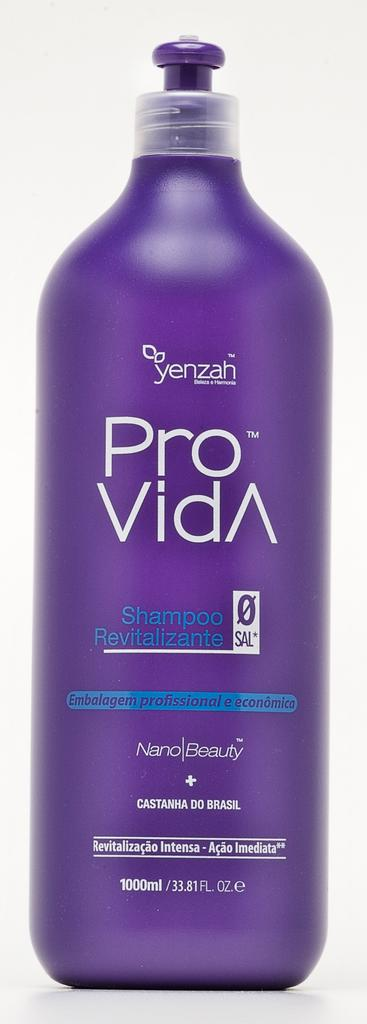<image>
Write a terse but informative summary of the picture. the words pro vida are on a purple bottle 